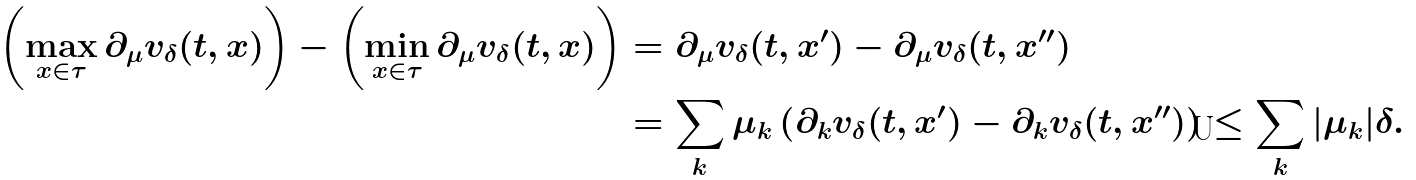Convert formula to latex. <formula><loc_0><loc_0><loc_500><loc_500>\left ( \max _ { x \in \tau } \partial _ { \mu } v _ { \delta } ( t , x ) \right ) - \left ( \min _ { x \in \tau } \partial _ { \mu } v _ { \delta } ( t , x ) \right ) & = \partial _ { \mu } v _ { \delta } ( t , x ^ { \prime } ) - \partial _ { \mu } v _ { \delta } ( t , x ^ { \prime \prime } ) \\ & = \sum _ { k } \mu _ { k } \left ( \partial _ { k } v _ { \delta } ( t , x ^ { \prime } ) - \partial _ { k } v _ { \delta } ( t , x ^ { \prime \prime } ) \right ) \leq \sum _ { k } | \mu _ { k } | \delta .</formula> 